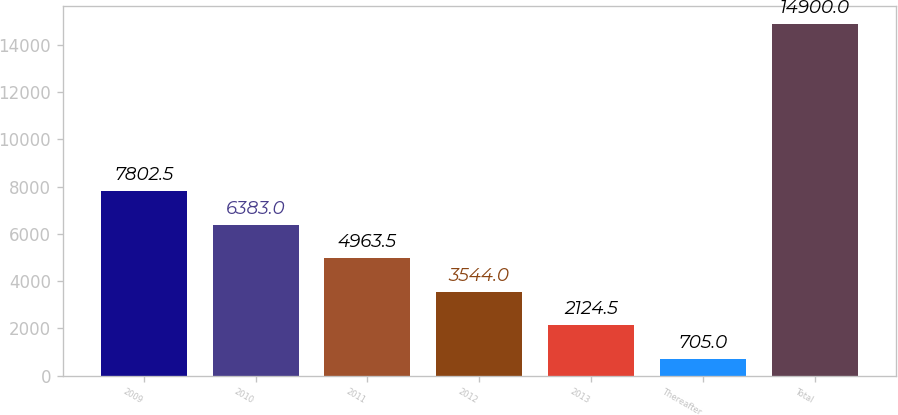Convert chart. <chart><loc_0><loc_0><loc_500><loc_500><bar_chart><fcel>2009<fcel>2010<fcel>2011<fcel>2012<fcel>2013<fcel>Thereafter<fcel>Total<nl><fcel>7802.5<fcel>6383<fcel>4963.5<fcel>3544<fcel>2124.5<fcel>705<fcel>14900<nl></chart> 